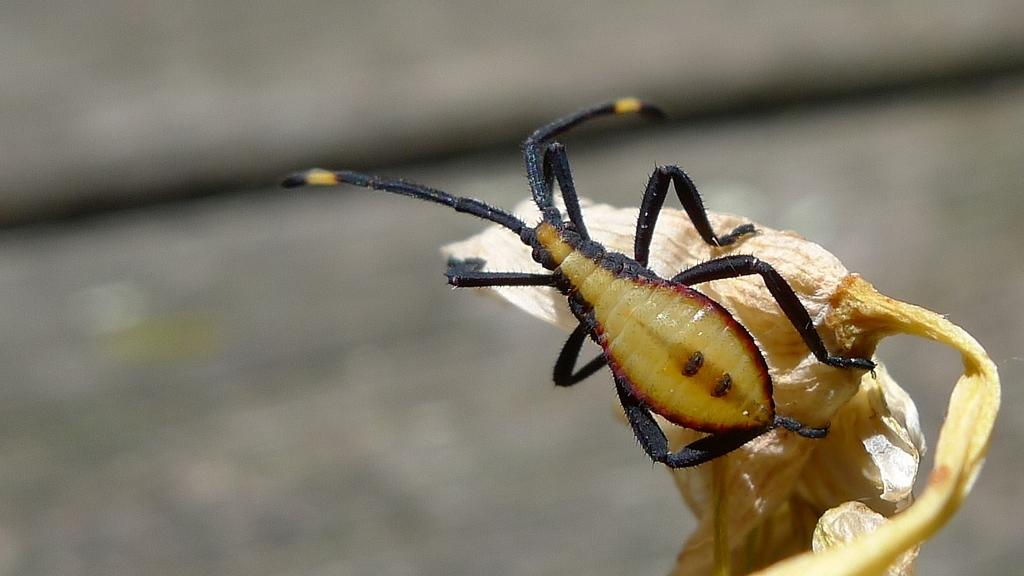What is the main subject of the picture? The main subject of the picture is an insect. Where is the insect located in the image? The insect is on a flower. Can you describe the background of the image? The background of the image is blurry. What organization is responsible for the yearly event depicted in the image? There is no event or organization mentioned in the image; it features an insect on a flower with a blurry background. 